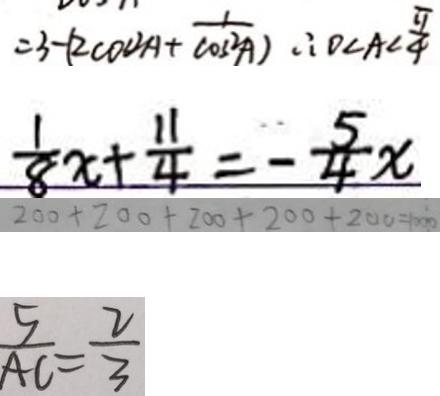Convert formula to latex. <formula><loc_0><loc_0><loc_500><loc_500>= 3 - ( 2 \cos ^ { 2 } A + \frac { 1 } { \cos ^ { 2 } A } ) \therefore 0 < A < \frac { \pi } { 4 } 
 \frac { 1 } { 8 } x + \frac { 1 1 } { 4 } = - \frac { 5 } { 4 } x 
 2 0 0 + 2 0 0 + 2 0 0 + 2 0 0 + 2 0 0 = 1 0 0 0 
 \frac { 5 } { A C } = \frac { 2 } { 3 }</formula> 